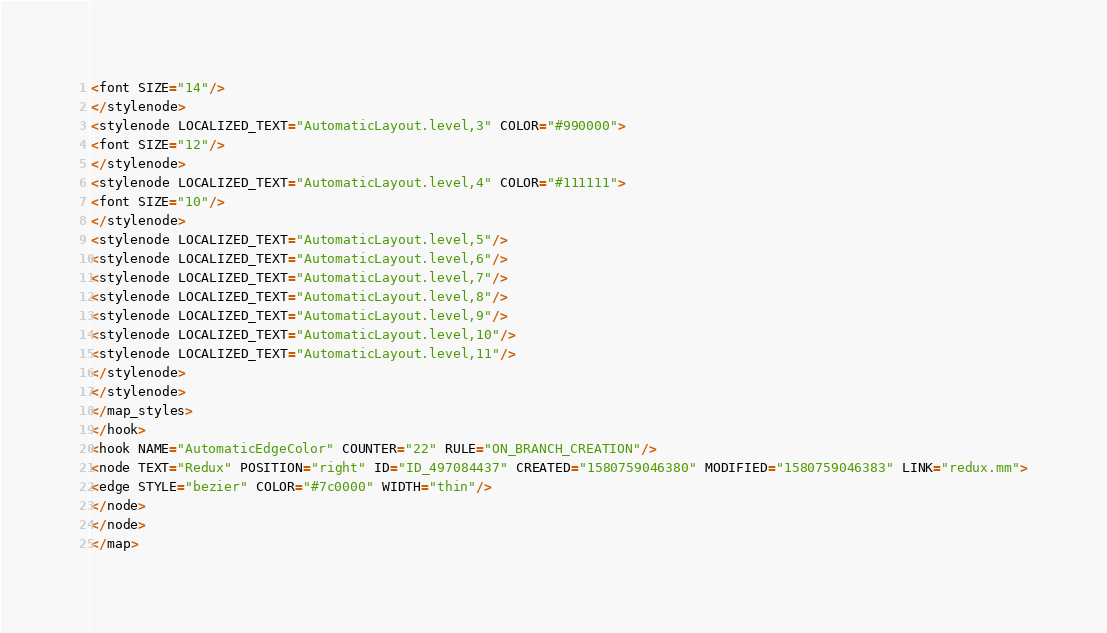<code> <loc_0><loc_0><loc_500><loc_500><_ObjectiveC_><font SIZE="14"/>
</stylenode>
<stylenode LOCALIZED_TEXT="AutomaticLayout.level,3" COLOR="#990000">
<font SIZE="12"/>
</stylenode>
<stylenode LOCALIZED_TEXT="AutomaticLayout.level,4" COLOR="#111111">
<font SIZE="10"/>
</stylenode>
<stylenode LOCALIZED_TEXT="AutomaticLayout.level,5"/>
<stylenode LOCALIZED_TEXT="AutomaticLayout.level,6"/>
<stylenode LOCALIZED_TEXT="AutomaticLayout.level,7"/>
<stylenode LOCALIZED_TEXT="AutomaticLayout.level,8"/>
<stylenode LOCALIZED_TEXT="AutomaticLayout.level,9"/>
<stylenode LOCALIZED_TEXT="AutomaticLayout.level,10"/>
<stylenode LOCALIZED_TEXT="AutomaticLayout.level,11"/>
</stylenode>
</stylenode>
</map_styles>
</hook>
<hook NAME="AutomaticEdgeColor" COUNTER="22" RULE="ON_BRANCH_CREATION"/>
<node TEXT="Redux" POSITION="right" ID="ID_497084437" CREATED="1580759046380" MODIFIED="1580759046383" LINK="redux.mm">
<edge STYLE="bezier" COLOR="#7c0000" WIDTH="thin"/>
</node>
</node>
</map>
</code> 